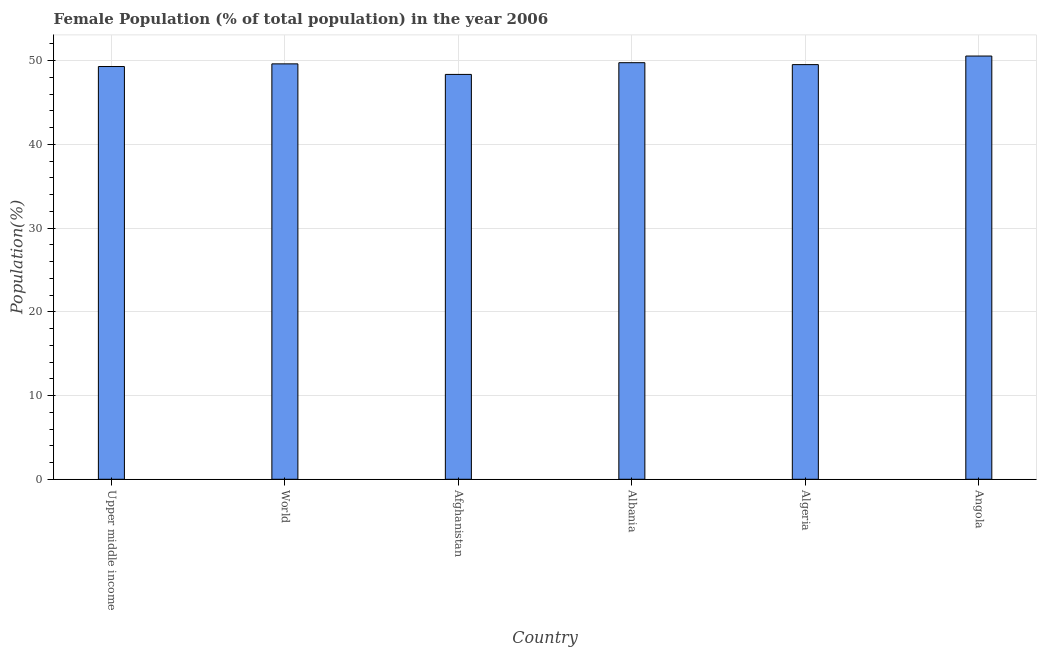Does the graph contain any zero values?
Offer a terse response. No. What is the title of the graph?
Provide a succinct answer. Female Population (% of total population) in the year 2006. What is the label or title of the X-axis?
Offer a very short reply. Country. What is the label or title of the Y-axis?
Make the answer very short. Population(%). What is the female population in Albania?
Ensure brevity in your answer.  49.74. Across all countries, what is the maximum female population?
Offer a very short reply. 50.54. Across all countries, what is the minimum female population?
Your answer should be very brief. 48.34. In which country was the female population maximum?
Offer a terse response. Angola. In which country was the female population minimum?
Give a very brief answer. Afghanistan. What is the sum of the female population?
Your answer should be compact. 297.01. What is the difference between the female population in Algeria and Upper middle income?
Ensure brevity in your answer.  0.23. What is the average female population per country?
Your answer should be compact. 49.5. What is the median female population?
Ensure brevity in your answer.  49.56. In how many countries, is the female population greater than 14 %?
Your answer should be very brief. 6. Is the female population in Afghanistan less than that in Upper middle income?
Provide a short and direct response. Yes. What is the difference between the highest and the second highest female population?
Provide a short and direct response. 0.8. Is the sum of the female population in Algeria and Upper middle income greater than the maximum female population across all countries?
Ensure brevity in your answer.  Yes. What is the difference between the highest and the lowest female population?
Your answer should be very brief. 2.19. In how many countries, is the female population greater than the average female population taken over all countries?
Keep it short and to the point. 4. How many bars are there?
Give a very brief answer. 6. Are all the bars in the graph horizontal?
Your response must be concise. No. Are the values on the major ticks of Y-axis written in scientific E-notation?
Give a very brief answer. No. What is the Population(%) of Upper middle income?
Make the answer very short. 49.28. What is the Population(%) of World?
Provide a succinct answer. 49.6. What is the Population(%) of Afghanistan?
Your answer should be very brief. 48.34. What is the Population(%) in Albania?
Offer a very short reply. 49.74. What is the Population(%) in Algeria?
Offer a very short reply. 49.51. What is the Population(%) of Angola?
Provide a short and direct response. 50.54. What is the difference between the Population(%) in Upper middle income and World?
Keep it short and to the point. -0.32. What is the difference between the Population(%) in Upper middle income and Afghanistan?
Offer a terse response. 0.94. What is the difference between the Population(%) in Upper middle income and Albania?
Give a very brief answer. -0.46. What is the difference between the Population(%) in Upper middle income and Algeria?
Offer a very short reply. -0.23. What is the difference between the Population(%) in Upper middle income and Angola?
Make the answer very short. -1.25. What is the difference between the Population(%) in World and Afghanistan?
Offer a very short reply. 1.26. What is the difference between the Population(%) in World and Albania?
Ensure brevity in your answer.  -0.14. What is the difference between the Population(%) in World and Algeria?
Give a very brief answer. 0.09. What is the difference between the Population(%) in World and Angola?
Give a very brief answer. -0.93. What is the difference between the Population(%) in Afghanistan and Albania?
Provide a succinct answer. -1.4. What is the difference between the Population(%) in Afghanistan and Algeria?
Your answer should be compact. -1.17. What is the difference between the Population(%) in Afghanistan and Angola?
Keep it short and to the point. -2.19. What is the difference between the Population(%) in Albania and Algeria?
Your response must be concise. 0.23. What is the difference between the Population(%) in Albania and Angola?
Give a very brief answer. -0.8. What is the difference between the Population(%) in Algeria and Angola?
Make the answer very short. -1.02. What is the ratio of the Population(%) in Upper middle income to that in Algeria?
Keep it short and to the point. 0.99. What is the ratio of the Population(%) in Upper middle income to that in Angola?
Keep it short and to the point. 0.97. What is the ratio of the Population(%) in World to that in Albania?
Offer a terse response. 1. What is the ratio of the Population(%) in World to that in Algeria?
Your answer should be very brief. 1. What is the ratio of the Population(%) in World to that in Angola?
Your answer should be compact. 0.98. What is the ratio of the Population(%) in Afghanistan to that in Albania?
Offer a terse response. 0.97. What is the ratio of the Population(%) in Afghanistan to that in Angola?
Ensure brevity in your answer.  0.96. What is the ratio of the Population(%) in Albania to that in Algeria?
Ensure brevity in your answer.  1. What is the ratio of the Population(%) in Albania to that in Angola?
Provide a succinct answer. 0.98. What is the ratio of the Population(%) in Algeria to that in Angola?
Your answer should be very brief. 0.98. 